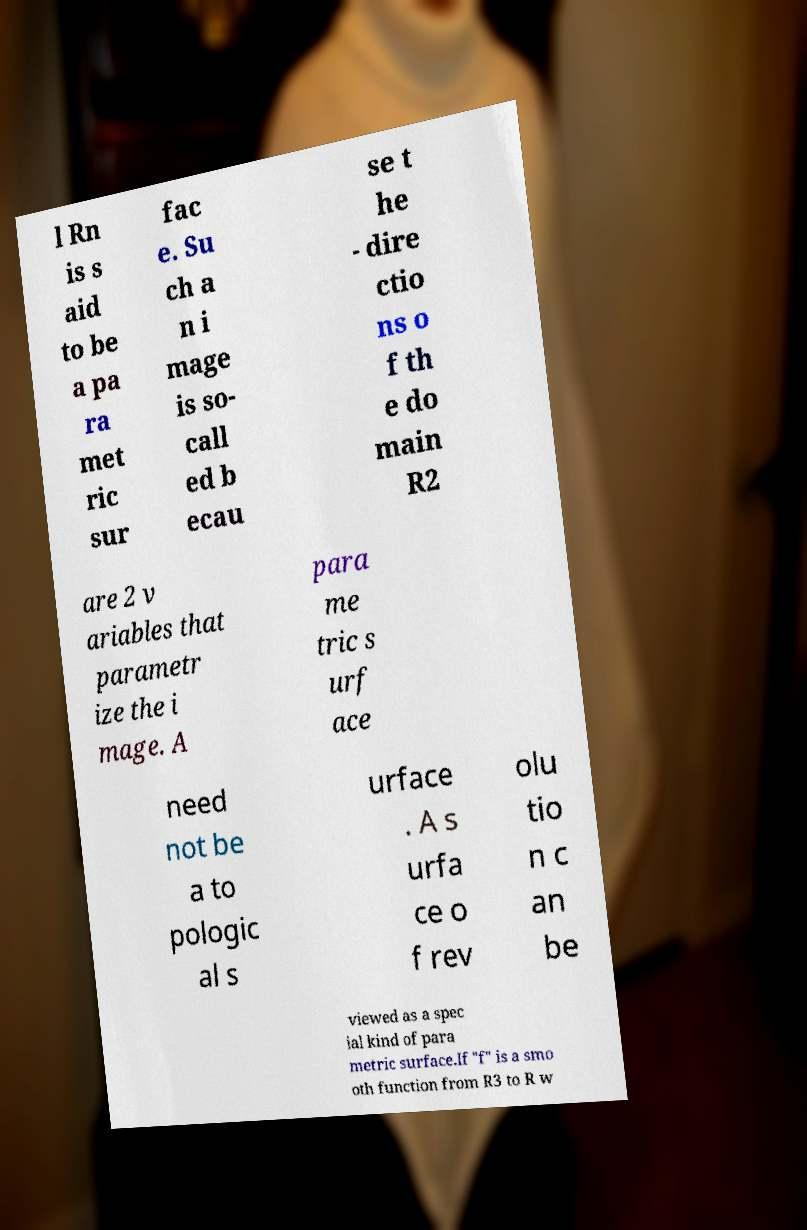Please identify and transcribe the text found in this image. l Rn is s aid to be a pa ra met ric sur fac e. Su ch a n i mage is so- call ed b ecau se t he - dire ctio ns o f th e do main R2 are 2 v ariables that parametr ize the i mage. A para me tric s urf ace need not be a to pologic al s urface . A s urfa ce o f rev olu tio n c an be viewed as a spec ial kind of para metric surface.If "f" is a smo oth function from R3 to R w 